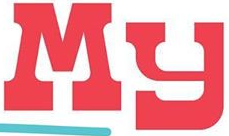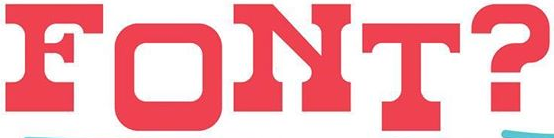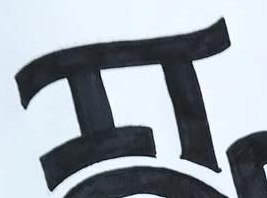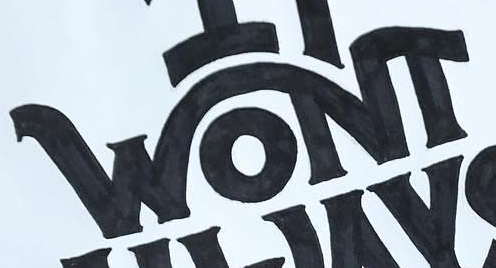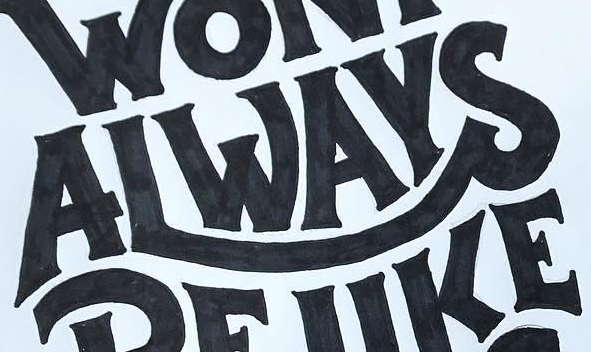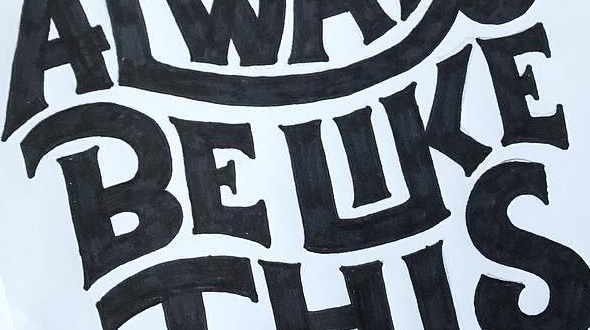What words can you see in these images in sequence, separated by a semicolon? My; FONT?; IT; WONT; ALWAYS; BELIKE 